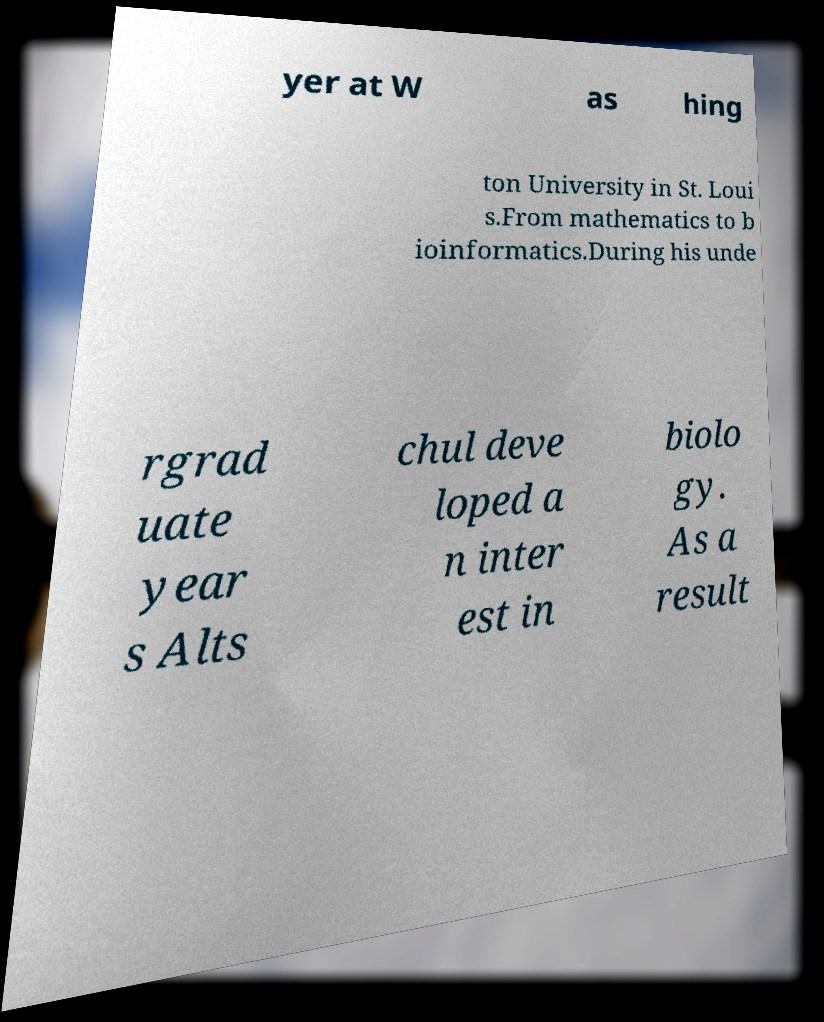Please identify and transcribe the text found in this image. yer at W as hing ton University in St. Loui s.From mathematics to b ioinformatics.During his unde rgrad uate year s Alts chul deve loped a n inter est in biolo gy. As a result 